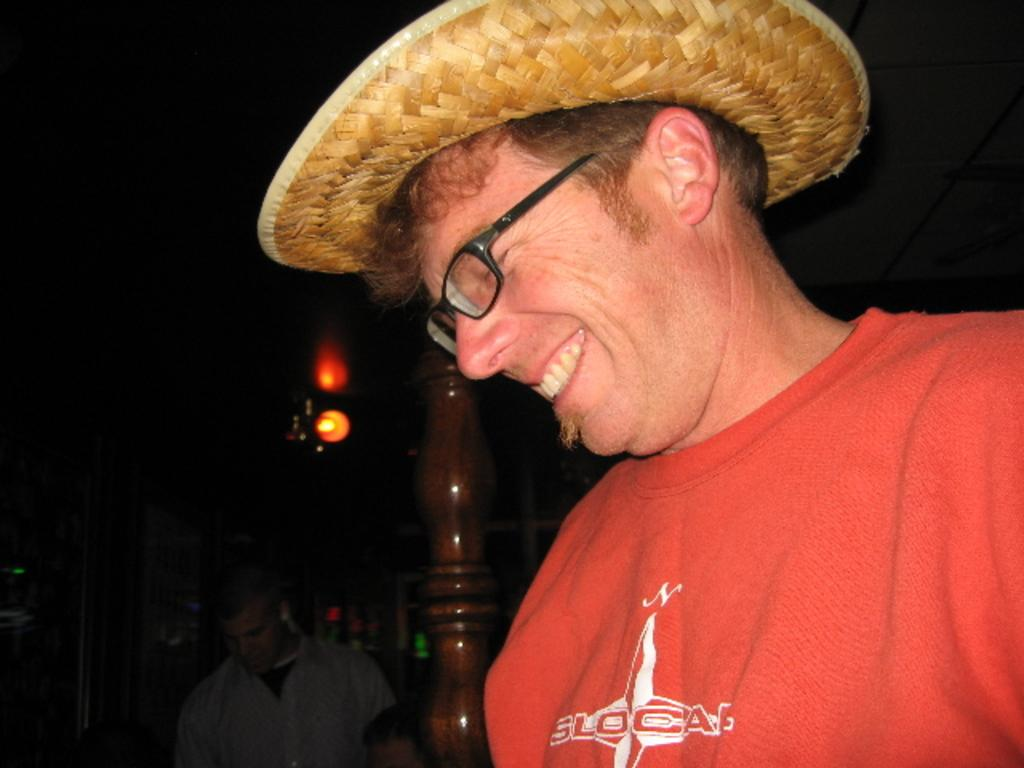How many people are in the image? There are two persons in the image. Can you describe one of the persons in the image? One of the persons is a man. What is the man wearing in the image? The man is wearing a hat. What can be seen in the background of the image? There are objects in the dark background of the image. What type of news can be heard coming from the hospital in the image? There is no hospital or news present in the image; it features two persons, one of whom is a man wearing a hat. What kind of stone is visible in the image? There is no stone present in the image. 